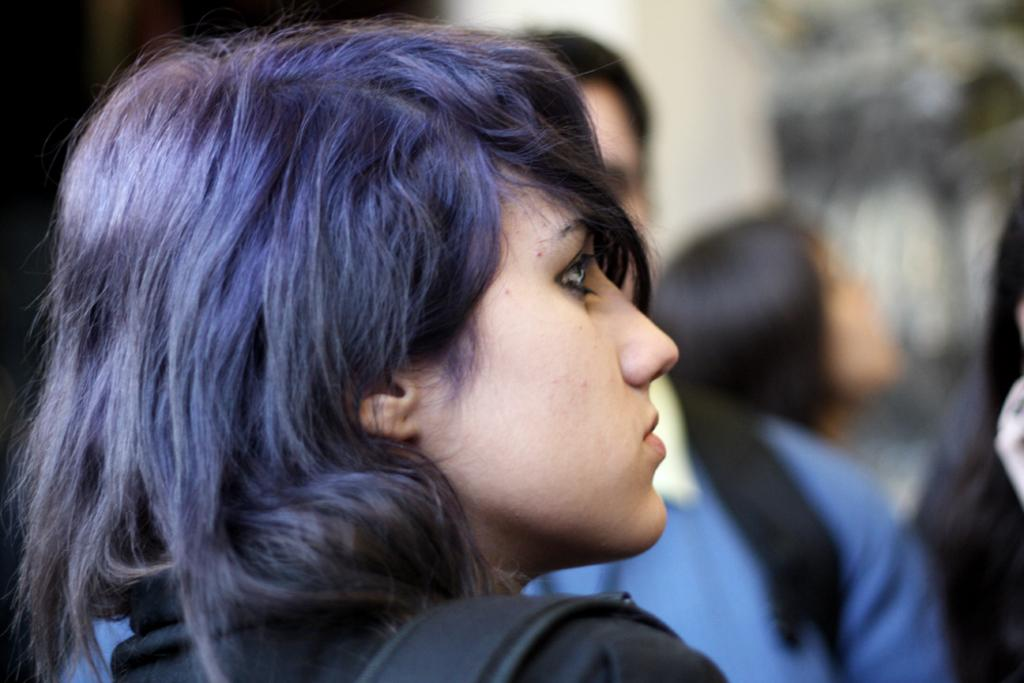What can be seen in the image? There are people in the image. Can you describe the background of the image? The background of the image is blurred. What type of drug is being discussed by the people in the image? There is no indication in the image that the people are discussing any drugs, so it cannot be determined from the picture. 